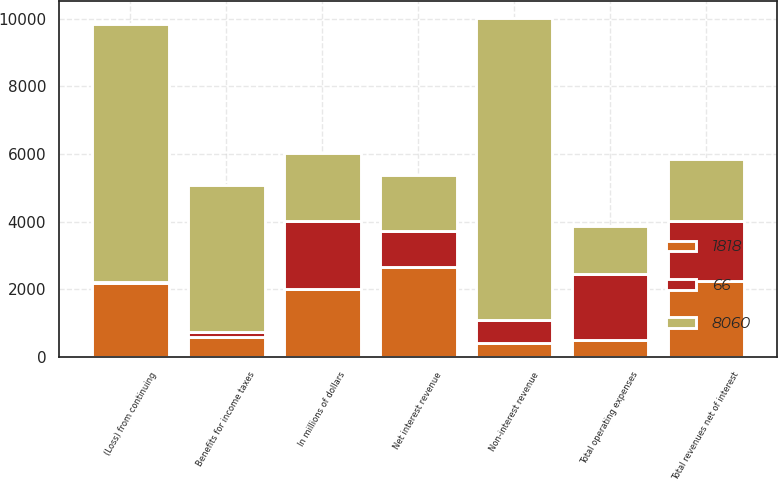<chart> <loc_0><loc_0><loc_500><loc_500><stacked_bar_chart><ecel><fcel>In millions of dollars<fcel>Net interest revenue<fcel>Non-interest revenue<fcel>Total revenues net of interest<fcel>Total operating expenses<fcel>(Loss) from continuing<fcel>Benefits for income taxes<nl><fcel>66<fcel>2010<fcel>1059<fcel>695<fcel>1754<fcel>1953<fcel>46<fcel>153<nl><fcel>8060<fcel>2009<fcel>1657<fcel>8898<fcel>1853.5<fcel>1418<fcel>7617<fcel>4356<nl><fcel>1818<fcel>2008<fcel>2671<fcel>413<fcel>2258<fcel>511<fcel>2184<fcel>585<nl></chart> 